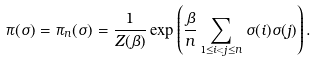Convert formula to latex. <formula><loc_0><loc_0><loc_500><loc_500>\pi ( \sigma ) = \pi _ { n } ( \sigma ) = \frac { 1 } { Z ( \beta ) } \exp \left ( \frac { \beta } { n } \sum _ { 1 \leq i < j \leq n } \sigma ( i ) \sigma ( j ) \right ) .</formula> 